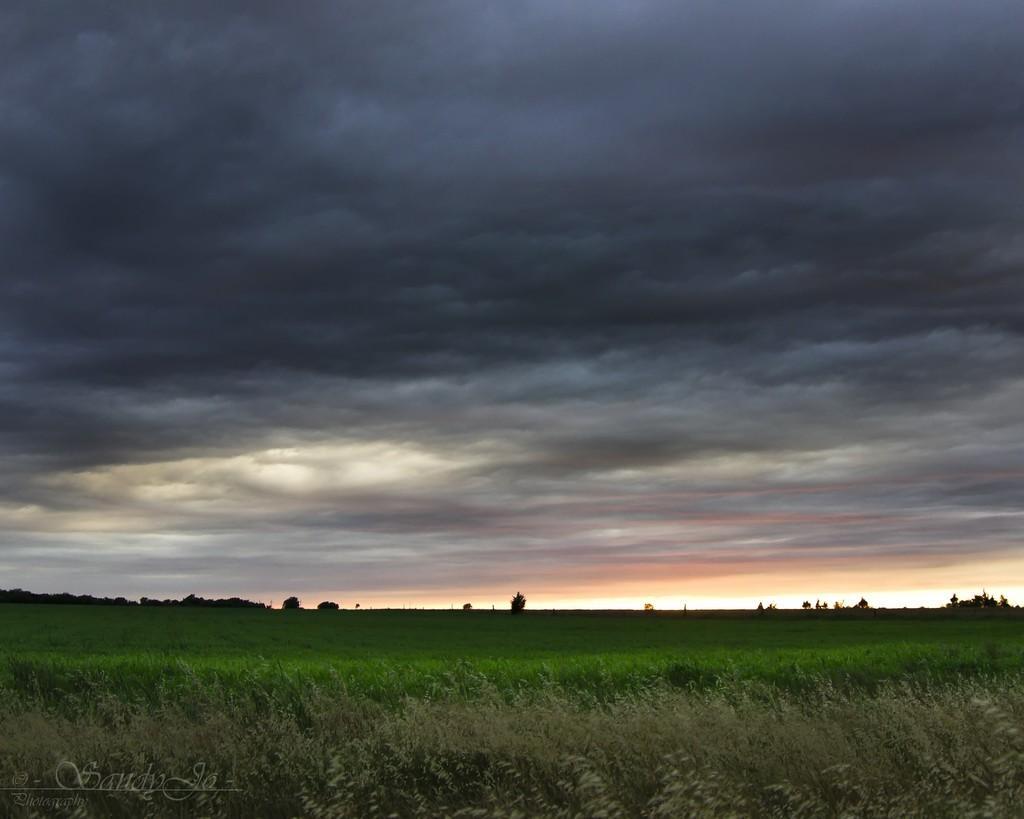Describe this image in one or two sentences. This picture is clicked outside the city. In the foreground we can see the green grass. In the background we can see the trees and the sky which is full of clouds. In the bottom left corner there is a watermark on the image. 